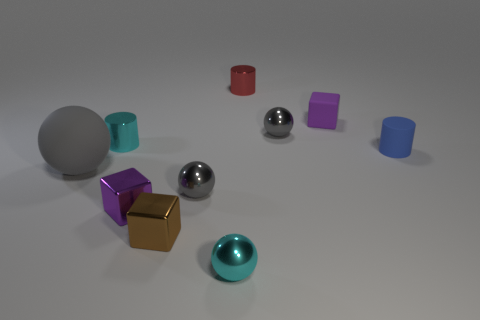How many gray spheres must be subtracted to get 1 gray spheres? 2 Subtract all gray balls. How many balls are left? 1 Subtract all red balls. How many purple blocks are left? 2 Subtract all brown cubes. How many cubes are left? 2 Subtract all blocks. How many objects are left? 7 Subtract 2 spheres. How many spheres are left? 2 Subtract all red blocks. Subtract all yellow cylinders. How many blocks are left? 3 Subtract all large objects. Subtract all purple objects. How many objects are left? 7 Add 8 large gray matte spheres. How many large gray matte spheres are left? 9 Add 5 tiny purple rubber things. How many tiny purple rubber things exist? 6 